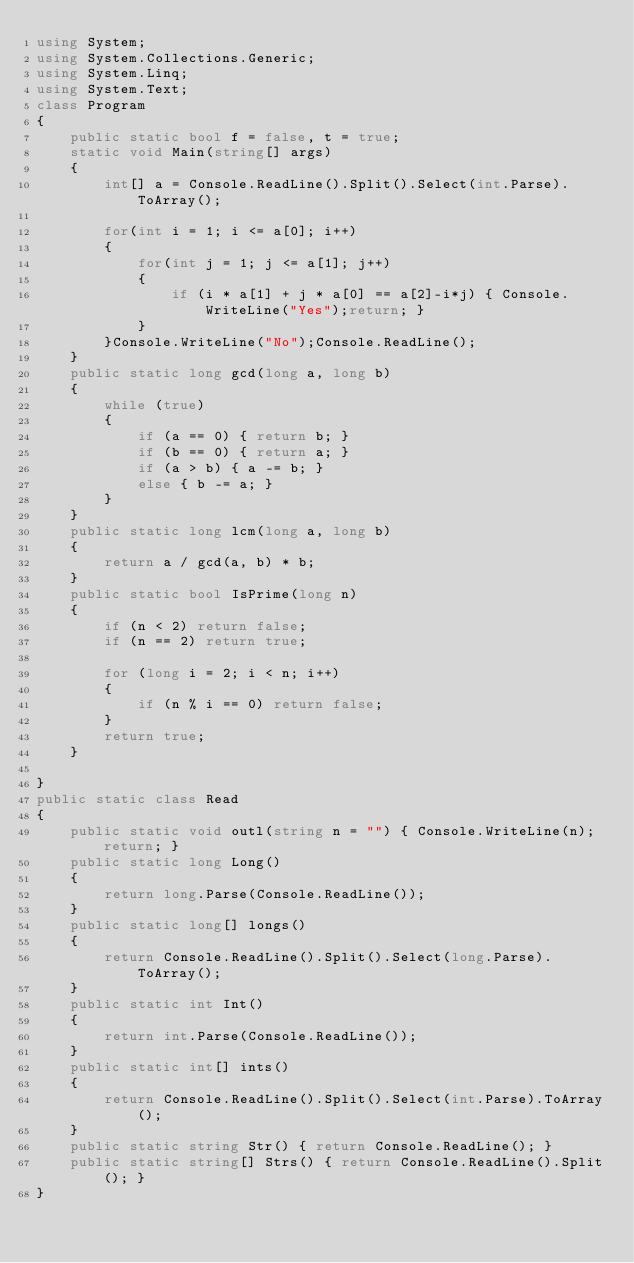Convert code to text. <code><loc_0><loc_0><loc_500><loc_500><_C#_>using System;
using System.Collections.Generic;
using System.Linq;
using System.Text;
class Program
{
    public static bool f = false, t = true;
    static void Main(string[] args)
    {
        int[] a = Console.ReadLine().Split().Select(int.Parse).ToArray();

        for(int i = 1; i <= a[0]; i++)
        {
            for(int j = 1; j <= a[1]; j++)
            {
                if (i * a[1] + j * a[0] == a[2]-i*j) { Console.WriteLine("Yes");return; }
            }
        }Console.WriteLine("No");Console.ReadLine();
    }
    public static long gcd(long a, long b)
    {
        while (true)
        {
            if (a == 0) { return b; }
            if (b == 0) { return a; }
            if (a > b) { a -= b; }
            else { b -= a; }
        }
    }
    public static long lcm(long a, long b)
    {
        return a / gcd(a, b) * b;
    }
    public static bool IsPrime(long n)
    {
        if (n < 2) return false;
        if (n == 2) return true;

        for (long i = 2; i < n; i++)
        {
            if (n % i == 0) return false;
        }
        return true;
    }

}
public static class Read
{
    public static void outl(string n = "") { Console.WriteLine(n); return; }
    public static long Long()
    {
        return long.Parse(Console.ReadLine());
    }
    public static long[] longs()
    {
        return Console.ReadLine().Split().Select(long.Parse).ToArray();
    }
    public static int Int()
    {
        return int.Parse(Console.ReadLine());
    }
    public static int[] ints()
    {
        return Console.ReadLine().Split().Select(int.Parse).ToArray();
    }
    public static string Str() { return Console.ReadLine(); }
    public static string[] Strs() { return Console.ReadLine().Split(); }
}</code> 